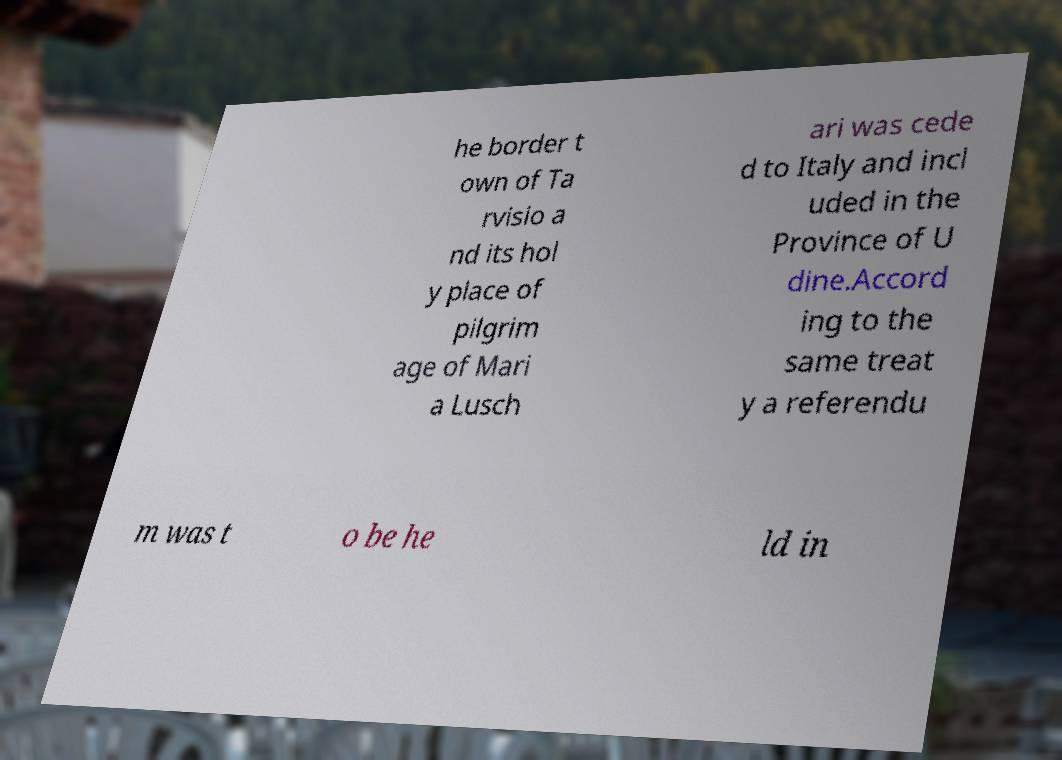There's text embedded in this image that I need extracted. Can you transcribe it verbatim? he border t own of Ta rvisio a nd its hol y place of pilgrim age of Mari a Lusch ari was cede d to Italy and incl uded in the Province of U dine.Accord ing to the same treat y a referendu m was t o be he ld in 